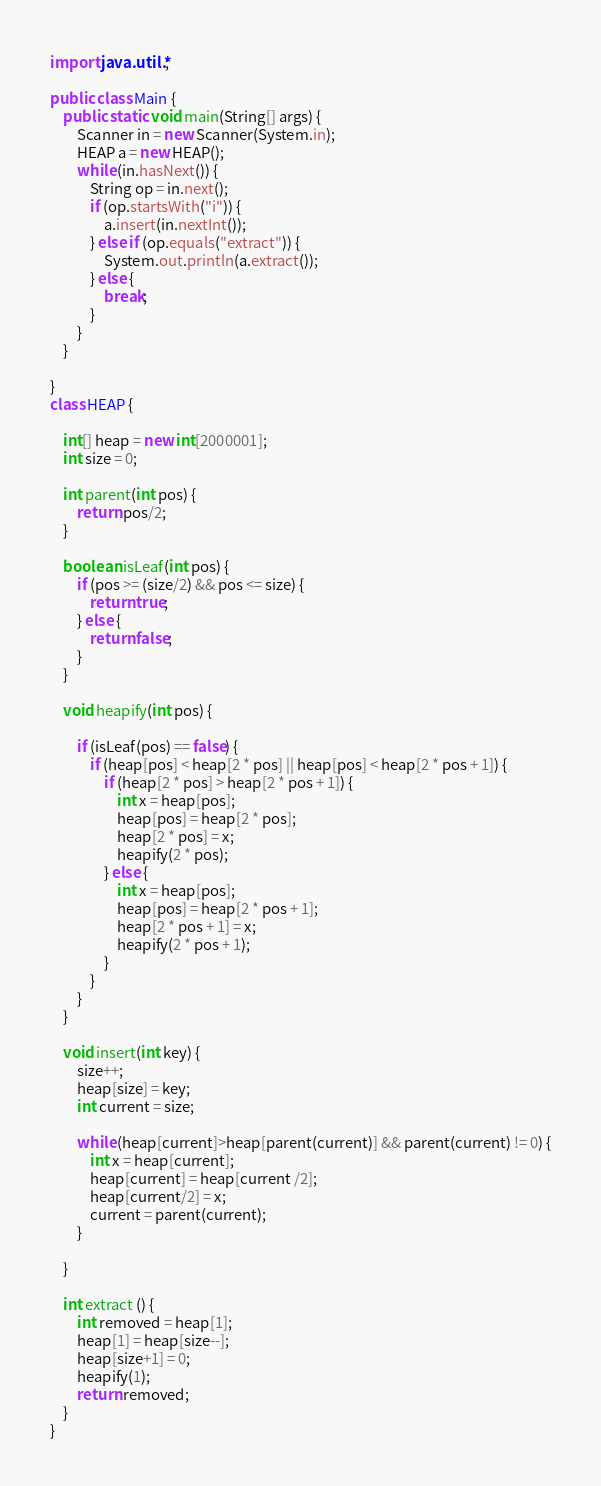<code> <loc_0><loc_0><loc_500><loc_500><_Java_>import java.util.*;

public class Main {
    public static void main(String[] args) {
        Scanner in = new Scanner(System.in);
        HEAP a = new HEAP();
        while (in.hasNext()) {
            String op = in.next();
            if (op.startsWith("i")) {
                a.insert(in.nextInt());
            } else if (op.equals("extract")) {
                System.out.println(a.extract());
            } else {
                break;
            }
        }
    }

}
class HEAP {

    int[] heap = new int[2000001];
    int size = 0;

    int parent(int pos) {
        return pos/2;
    }

    boolean isLeaf(int pos) {
        if (pos >= (size/2) && pos <= size) {
            return true;
        } else {
            return false;
        }
    }

    void heapify(int pos) {

        if (isLeaf(pos) == false) {
            if (heap[pos] < heap[2 * pos] || heap[pos] < heap[2 * pos + 1]) {
                if (heap[2 * pos] > heap[2 * pos + 1]) {
                    int x = heap[pos];
                    heap[pos] = heap[2 * pos];
                    heap[2 * pos] = x;
                    heapify(2 * pos);
                } else {
                    int x = heap[pos];
                    heap[pos] = heap[2 * pos + 1];
                    heap[2 * pos + 1] = x;
                    heapify(2 * pos + 1);
                }
            }
        }
    }

    void insert(int key) {
        size++;
        heap[size] = key;
        int current = size;

        while (heap[current]>heap[parent(current)] && parent(current) != 0) {
            int x = heap[current];
            heap[current] = heap[current /2];
            heap[current/2] = x;
            current = parent(current);
        }

    }

    int extract () {
        int removed = heap[1];
        heap[1] = heap[size--];
        heap[size+1] = 0;
        heapify(1);
        return removed;
    }
}

</code> 